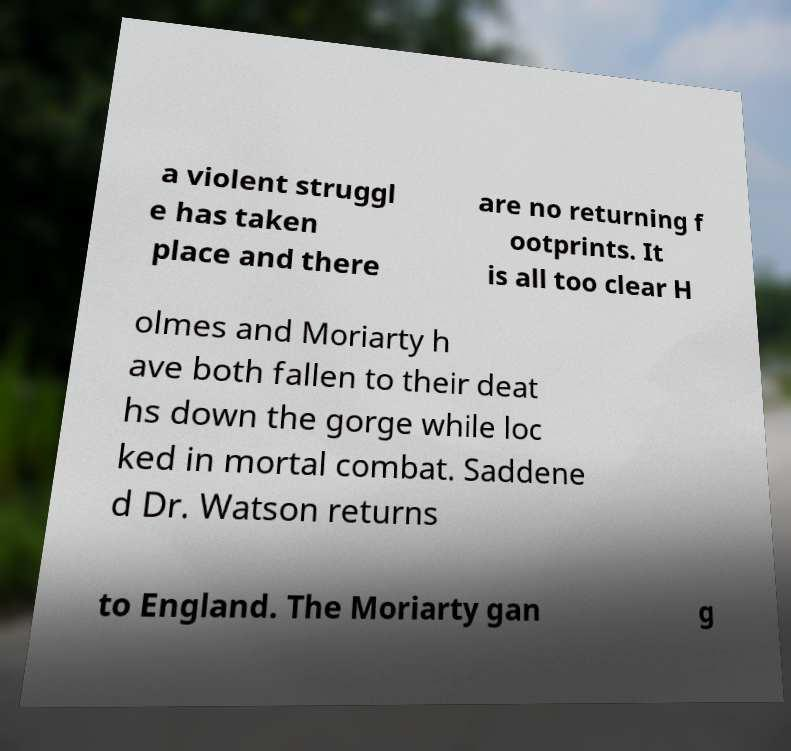I need the written content from this picture converted into text. Can you do that? a violent struggl e has taken place and there are no returning f ootprints. It is all too clear H olmes and Moriarty h ave both fallen to their deat hs down the gorge while loc ked in mortal combat. Saddene d Dr. Watson returns to England. The Moriarty gan g 